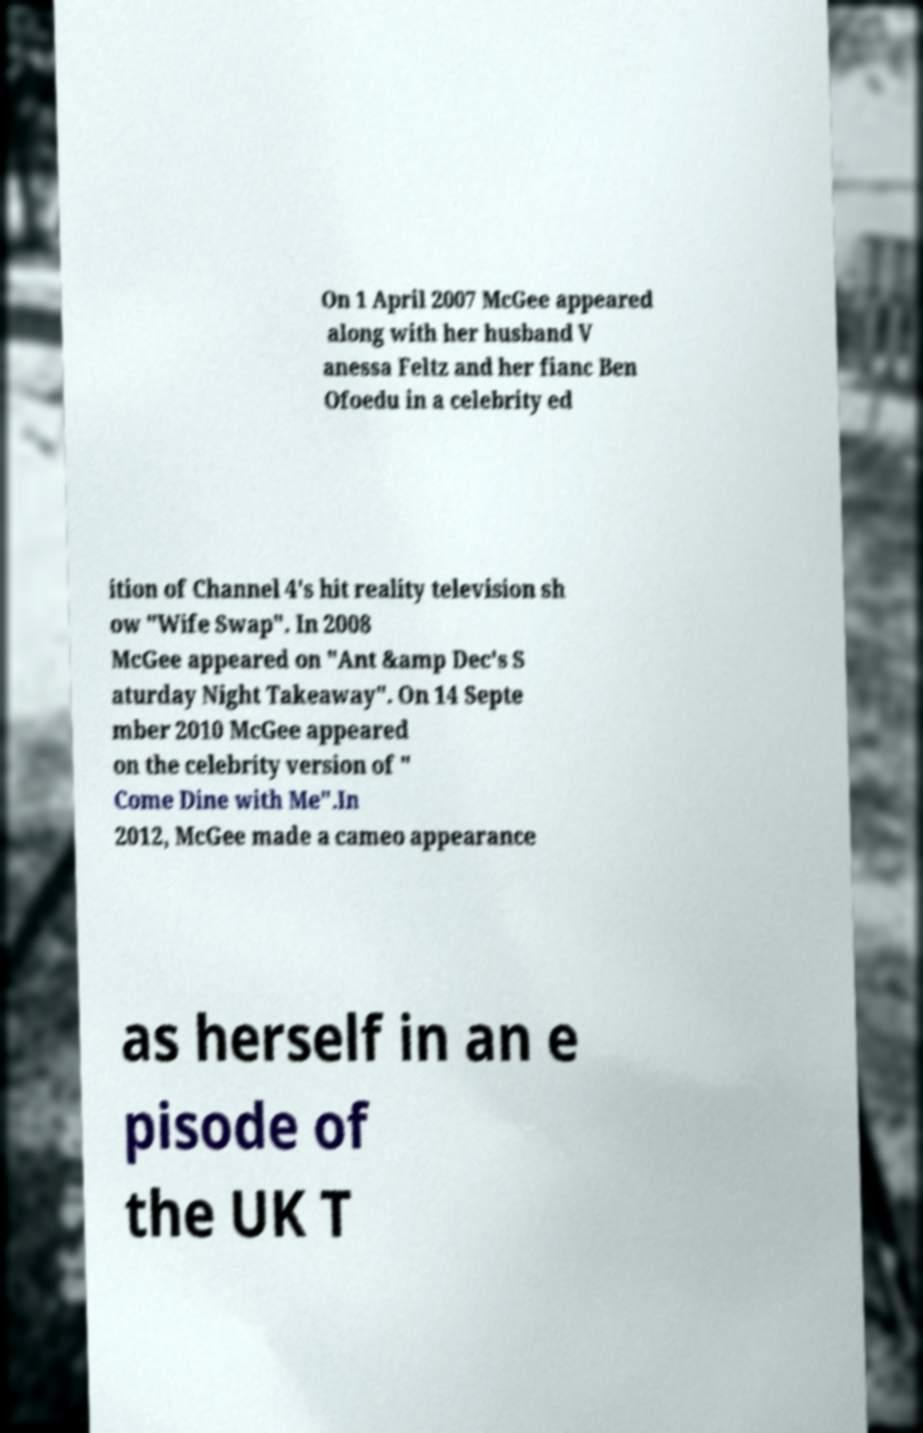Can you accurately transcribe the text from the provided image for me? On 1 April 2007 McGee appeared along with her husband V anessa Feltz and her fianc Ben Ofoedu in a celebrity ed ition of Channel 4's hit reality television sh ow "Wife Swap". In 2008 McGee appeared on "Ant &amp Dec's S aturday Night Takeaway". On 14 Septe mber 2010 McGee appeared on the celebrity version of " Come Dine with Me".In 2012, McGee made a cameo appearance as herself in an e pisode of the UK T 